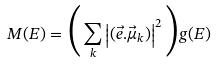Convert formula to latex. <formula><loc_0><loc_0><loc_500><loc_500>M ( E ) = \Big { ( } \sum _ { k } \left | ( \vec { e } . \vec { \mu } _ { k } ) \right | ^ { 2 } \Big { ) } g ( E )</formula> 